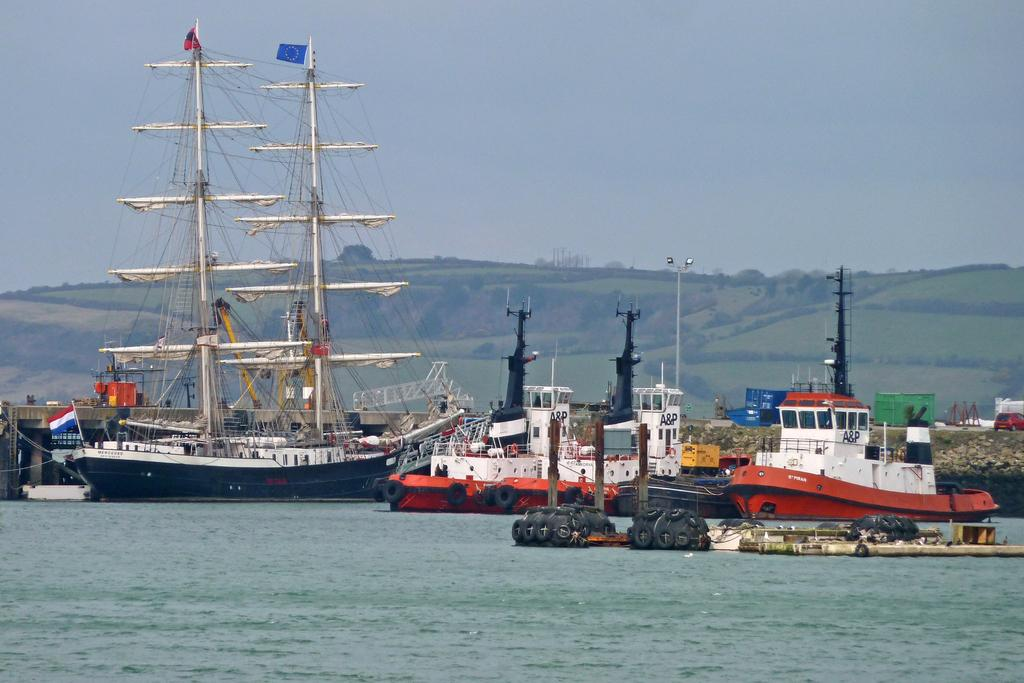What is the main subject of the image? The main subject of the image is many ships. Where are the ships located? The ships are on the water. What can be seen in the background of the image? The background of the image is the sky. What type of guitar is being played on the moon in the image? There is no guitar or moon present in the image; it features many ships on the water with the sky as the background. 